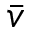Convert formula to latex. <formula><loc_0><loc_0><loc_500><loc_500>\bar { v }</formula> 